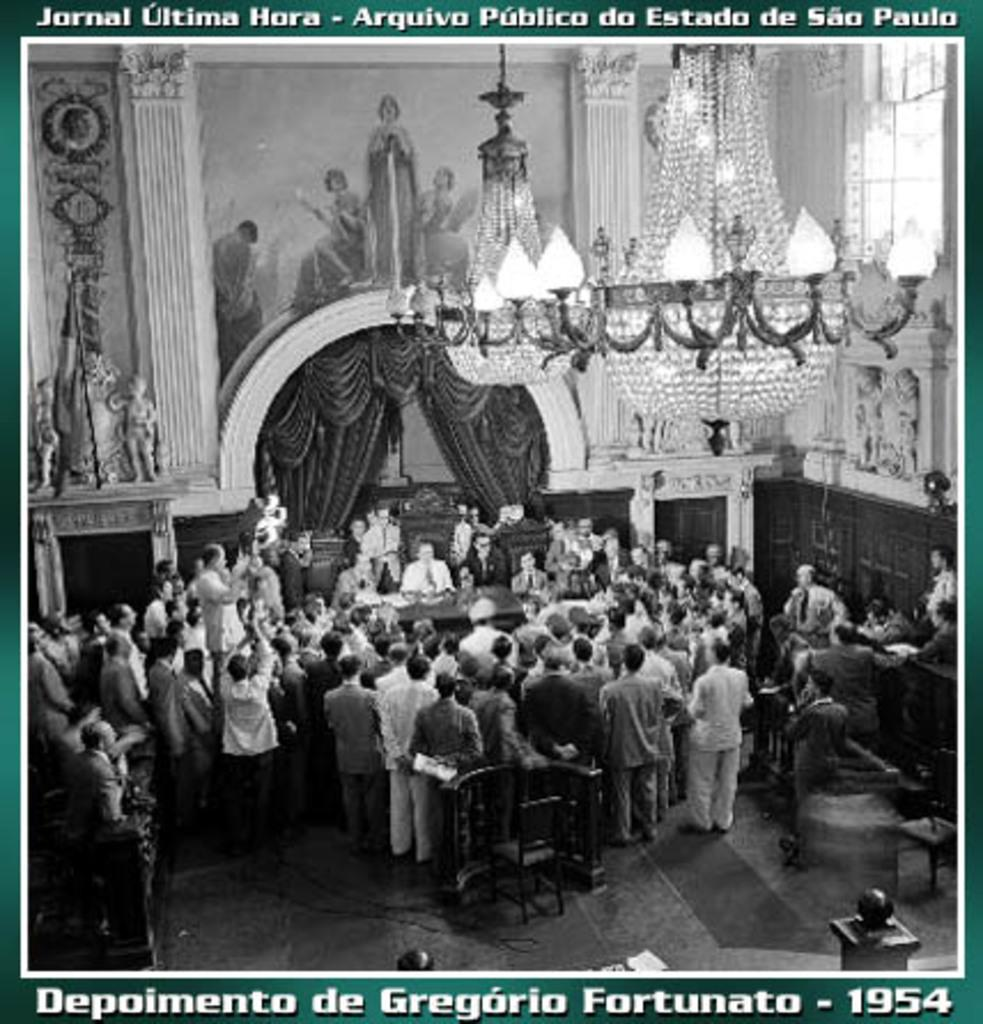What is happening inside the room in the image? There are people standing inside the room. Can you describe any specific features of the room? There is a chandelier hanging from the ceiling. How does the harbor affect the lighting in the room? There is no harbor present in the image, so it cannot affect the lighting in the room. 